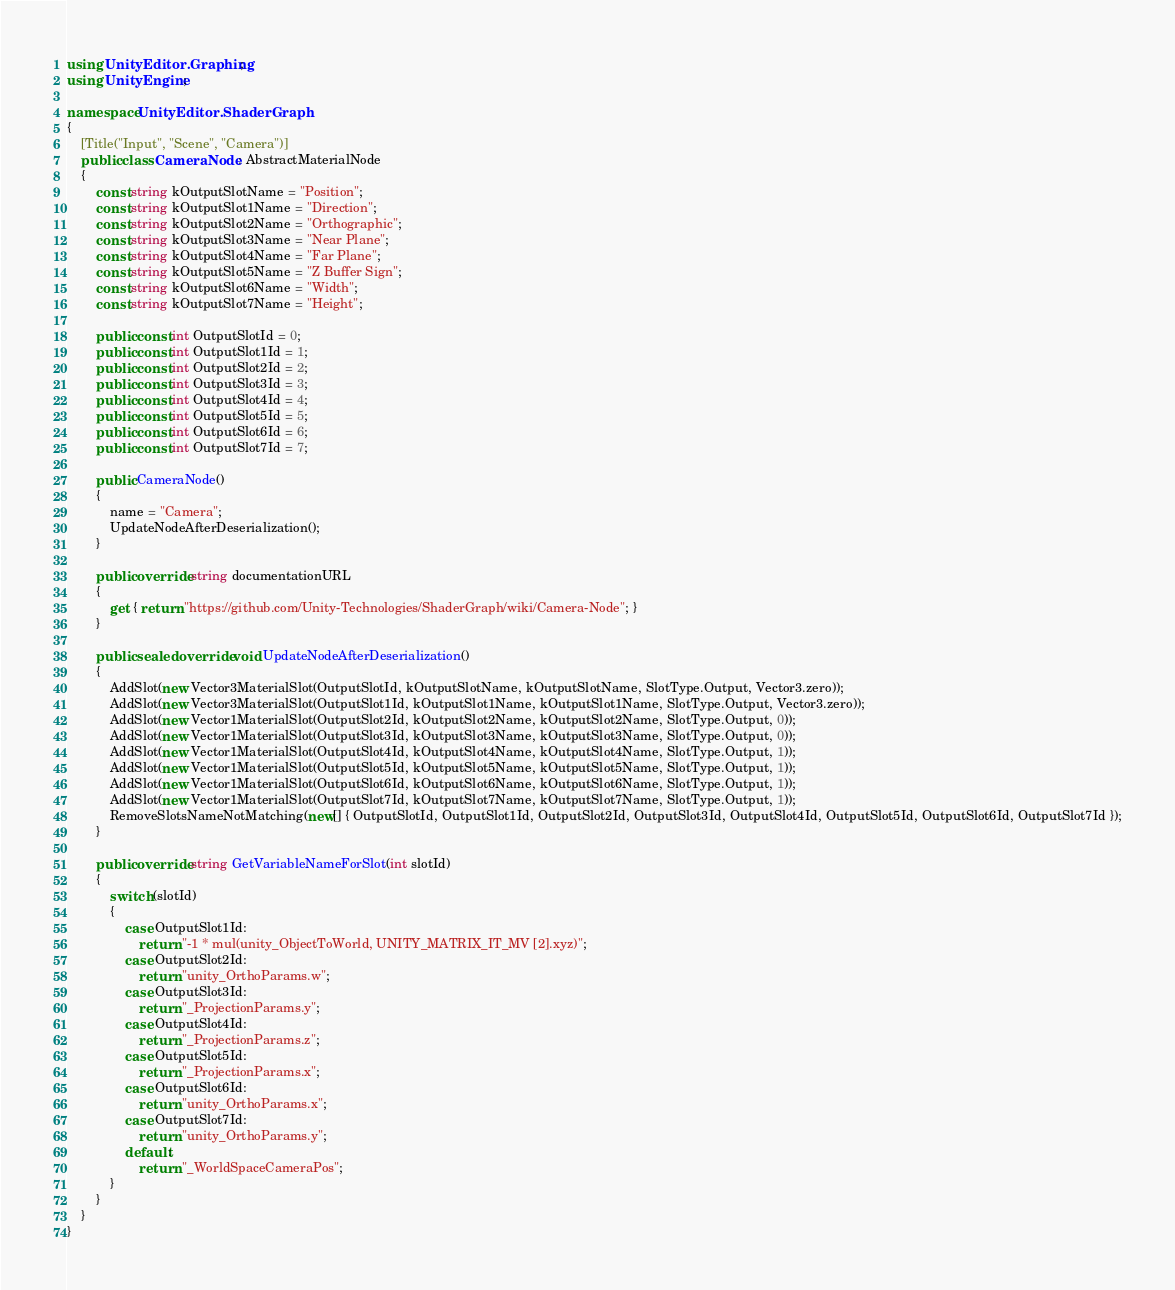<code> <loc_0><loc_0><loc_500><loc_500><_C#_>using UnityEditor.Graphing;
using UnityEngine;

namespace UnityEditor.ShaderGraph
{
    [Title("Input", "Scene", "Camera")]
    public class CameraNode : AbstractMaterialNode
    {
        const string kOutputSlotName = "Position";
        const string kOutputSlot1Name = "Direction";
        const string kOutputSlot2Name = "Orthographic";
        const string kOutputSlot3Name = "Near Plane";
        const string kOutputSlot4Name = "Far Plane";
        const string kOutputSlot5Name = "Z Buffer Sign";
        const string kOutputSlot6Name = "Width";
        const string kOutputSlot7Name = "Height";

        public const int OutputSlotId = 0;
        public const int OutputSlot1Id = 1;
        public const int OutputSlot2Id = 2;
        public const int OutputSlot3Id = 3;
        public const int OutputSlot4Id = 4;
        public const int OutputSlot5Id = 5;
        public const int OutputSlot6Id = 6;
        public const int OutputSlot7Id = 7;

        public CameraNode()
        {
            name = "Camera";
            UpdateNodeAfterDeserialization();
        }

        public override string documentationURL
        {
            get { return "https://github.com/Unity-Technologies/ShaderGraph/wiki/Camera-Node"; }
        }

        public sealed override void UpdateNodeAfterDeserialization()
        {
            AddSlot(new Vector3MaterialSlot(OutputSlotId, kOutputSlotName, kOutputSlotName, SlotType.Output, Vector3.zero));
            AddSlot(new Vector3MaterialSlot(OutputSlot1Id, kOutputSlot1Name, kOutputSlot1Name, SlotType.Output, Vector3.zero));
            AddSlot(new Vector1MaterialSlot(OutputSlot2Id, kOutputSlot2Name, kOutputSlot2Name, SlotType.Output, 0));
            AddSlot(new Vector1MaterialSlot(OutputSlot3Id, kOutputSlot3Name, kOutputSlot3Name, SlotType.Output, 0));
            AddSlot(new Vector1MaterialSlot(OutputSlot4Id, kOutputSlot4Name, kOutputSlot4Name, SlotType.Output, 1));
            AddSlot(new Vector1MaterialSlot(OutputSlot5Id, kOutputSlot5Name, kOutputSlot5Name, SlotType.Output, 1));
            AddSlot(new Vector1MaterialSlot(OutputSlot6Id, kOutputSlot6Name, kOutputSlot6Name, SlotType.Output, 1));
            AddSlot(new Vector1MaterialSlot(OutputSlot7Id, kOutputSlot7Name, kOutputSlot7Name, SlotType.Output, 1));
            RemoveSlotsNameNotMatching(new[] { OutputSlotId, OutputSlot1Id, OutputSlot2Id, OutputSlot3Id, OutputSlot4Id, OutputSlot5Id, OutputSlot6Id, OutputSlot7Id });
        }

        public override string GetVariableNameForSlot(int slotId)
        {
            switch (slotId)
            {
                case OutputSlot1Id:
                    return "-1 * mul(unity_ObjectToWorld, UNITY_MATRIX_IT_MV [2].xyz)";
                case OutputSlot2Id:
                    return "unity_OrthoParams.w";
                case OutputSlot3Id:
                    return "_ProjectionParams.y";
                case OutputSlot4Id:
                    return "_ProjectionParams.z";
                case OutputSlot5Id:
                    return "_ProjectionParams.x";
                case OutputSlot6Id:
                    return "unity_OrthoParams.x";
                case OutputSlot7Id:
                    return "unity_OrthoParams.y";
                default:
                    return "_WorldSpaceCameraPos";
            }
        }
    }
}
</code> 